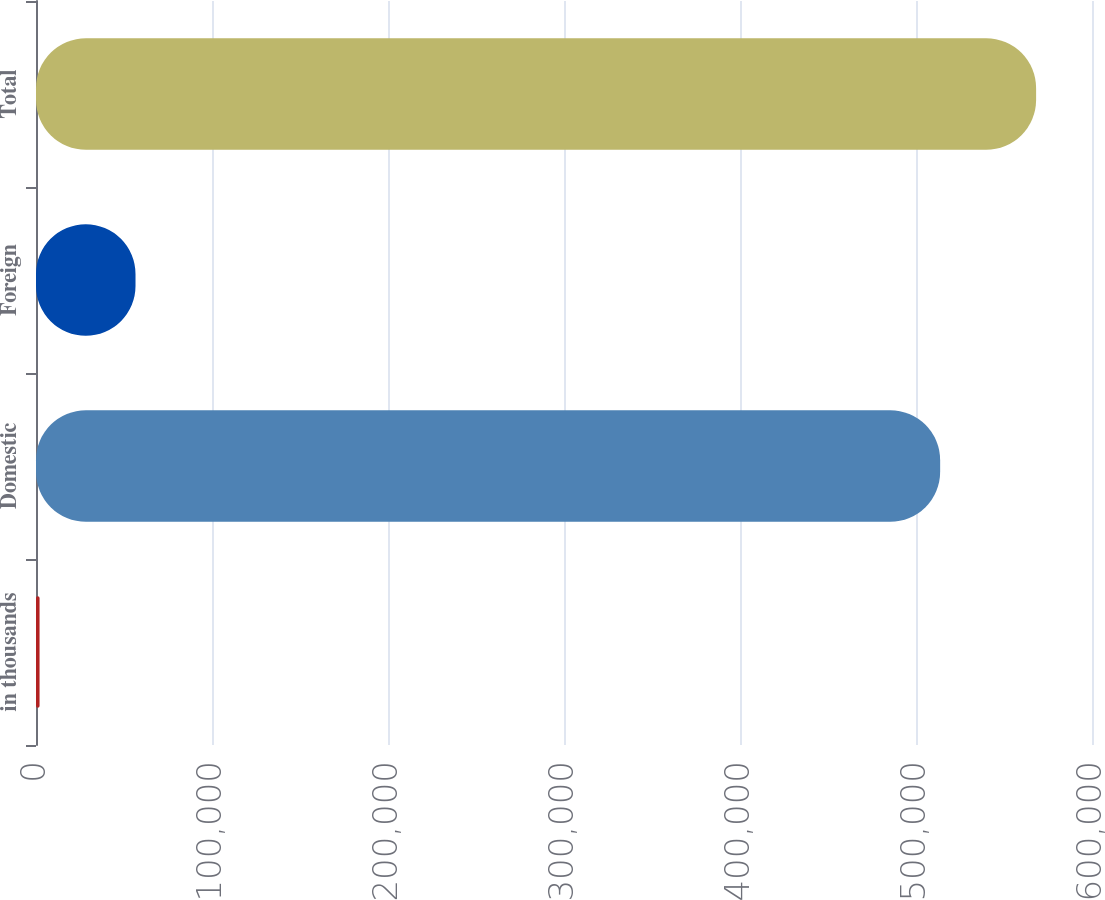Convert chart to OTSL. <chart><loc_0><loc_0><loc_500><loc_500><bar_chart><fcel>in thousands<fcel>Domestic<fcel>Foreign<fcel>Total<nl><fcel>2016<fcel>513721<fcel>56540.1<fcel>568245<nl></chart> 